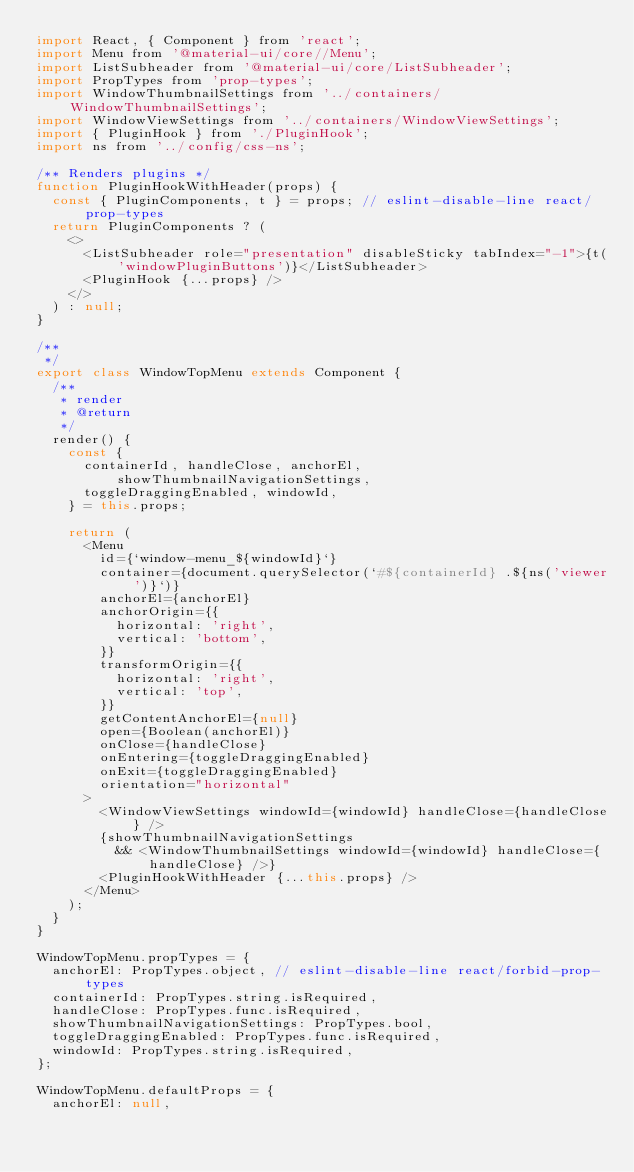Convert code to text. <code><loc_0><loc_0><loc_500><loc_500><_JavaScript_>import React, { Component } from 'react';
import Menu from '@material-ui/core//Menu';
import ListSubheader from '@material-ui/core/ListSubheader';
import PropTypes from 'prop-types';
import WindowThumbnailSettings from '../containers/WindowThumbnailSettings';
import WindowViewSettings from '../containers/WindowViewSettings';
import { PluginHook } from './PluginHook';
import ns from '../config/css-ns';

/** Renders plugins */
function PluginHookWithHeader(props) {
  const { PluginComponents, t } = props; // eslint-disable-line react/prop-types
  return PluginComponents ? (
    <>
      <ListSubheader role="presentation" disableSticky tabIndex="-1">{t('windowPluginButtons')}</ListSubheader>
      <PluginHook {...props} />
    </>
  ) : null;
}

/**
 */
export class WindowTopMenu extends Component {
  /**
   * render
   * @return
   */
  render() {
    const {
      containerId, handleClose, anchorEl, showThumbnailNavigationSettings,
      toggleDraggingEnabled, windowId,
    } = this.props;

    return (
      <Menu
        id={`window-menu_${windowId}`}
        container={document.querySelector(`#${containerId} .${ns('viewer')}`)}
        anchorEl={anchorEl}
        anchorOrigin={{
          horizontal: 'right',
          vertical: 'bottom',
        }}
        transformOrigin={{
          horizontal: 'right',
          vertical: 'top',
        }}
        getContentAnchorEl={null}
        open={Boolean(anchorEl)}
        onClose={handleClose}
        onEntering={toggleDraggingEnabled}
        onExit={toggleDraggingEnabled}
        orientation="horizontal"
      >
        <WindowViewSettings windowId={windowId} handleClose={handleClose} />
        {showThumbnailNavigationSettings
          && <WindowThumbnailSettings windowId={windowId} handleClose={handleClose} />}
        <PluginHookWithHeader {...this.props} />
      </Menu>
    );
  }
}

WindowTopMenu.propTypes = {
  anchorEl: PropTypes.object, // eslint-disable-line react/forbid-prop-types
  containerId: PropTypes.string.isRequired,
  handleClose: PropTypes.func.isRequired,
  showThumbnailNavigationSettings: PropTypes.bool,
  toggleDraggingEnabled: PropTypes.func.isRequired,
  windowId: PropTypes.string.isRequired,
};

WindowTopMenu.defaultProps = {
  anchorEl: null,</code> 